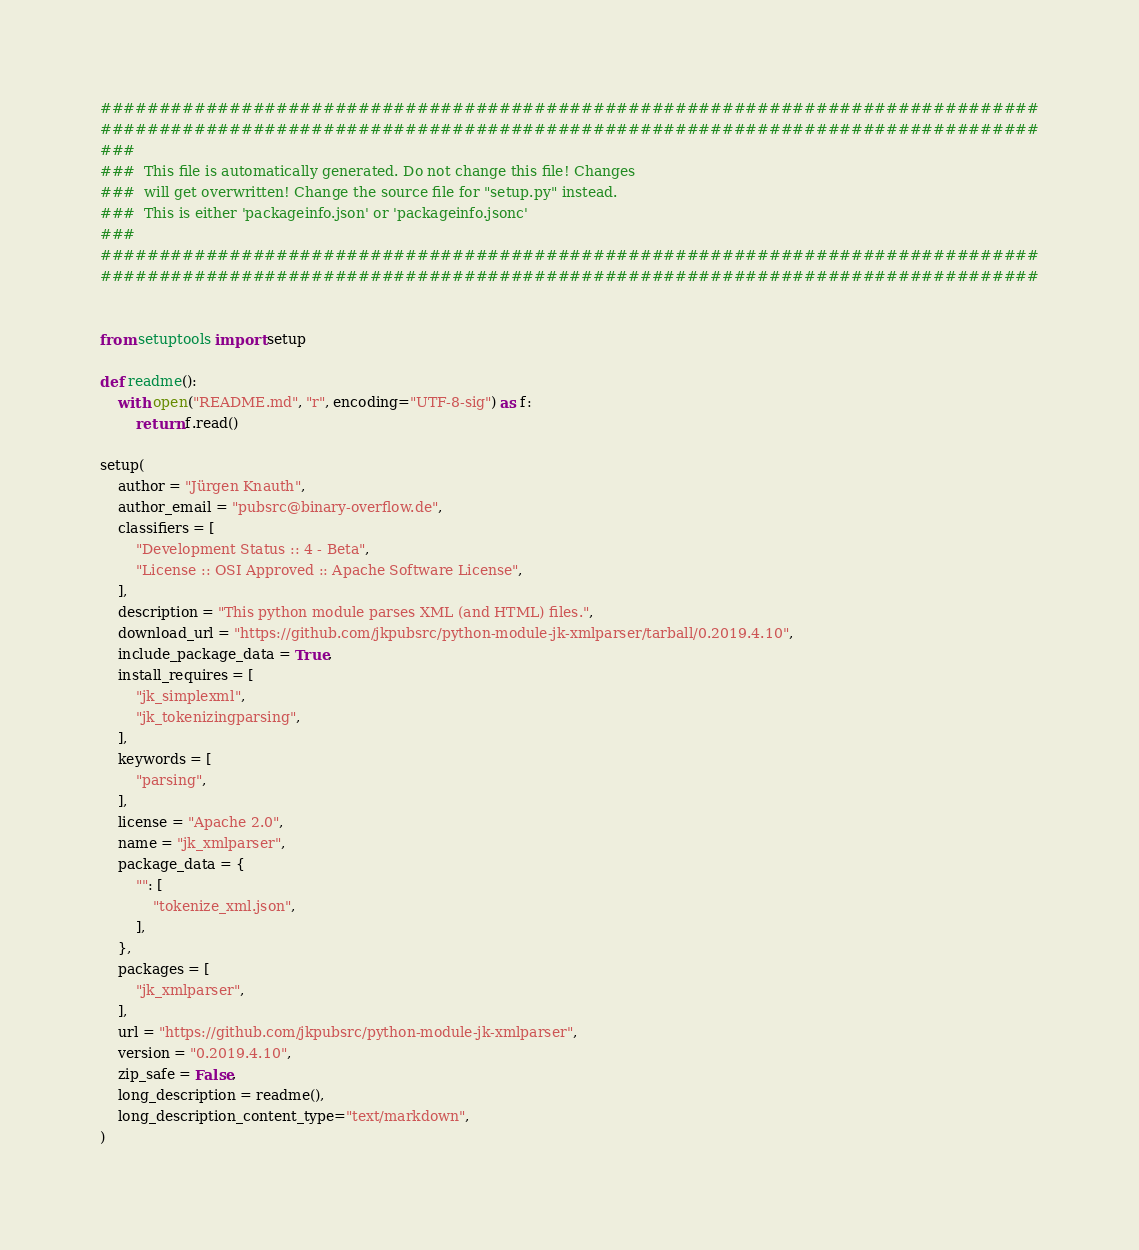Convert code to text. <code><loc_0><loc_0><loc_500><loc_500><_Python_>################################################################################
################################################################################
###
###  This file is automatically generated. Do not change this file! Changes
###  will get overwritten! Change the source file for "setup.py" instead.
###  This is either 'packageinfo.json' or 'packageinfo.jsonc'
###
################################################################################
################################################################################


from setuptools import setup

def readme():
	with open("README.md", "r", encoding="UTF-8-sig") as f:
		return f.read()

setup(
	author = "Jürgen Knauth",
	author_email = "pubsrc@binary-overflow.de",
	classifiers = [
		"Development Status :: 4 - Beta",
		"License :: OSI Approved :: Apache Software License",
	],
	description = "This python module parses XML (and HTML) files.",
	download_url = "https://github.com/jkpubsrc/python-module-jk-xmlparser/tarball/0.2019.4.10",
	include_package_data = True,
	install_requires = [
		"jk_simplexml",
		"jk_tokenizingparsing",
	],
	keywords = [
		"parsing",
	],
	license = "Apache 2.0",
	name = "jk_xmlparser",
	package_data = {
		"": [
			"tokenize_xml.json",
		],
	},
	packages = [
		"jk_xmlparser",
	],
	url = "https://github.com/jkpubsrc/python-module-jk-xmlparser",
	version = "0.2019.4.10",
	zip_safe = False,
	long_description = readme(),
	long_description_content_type="text/markdown",
)
</code> 